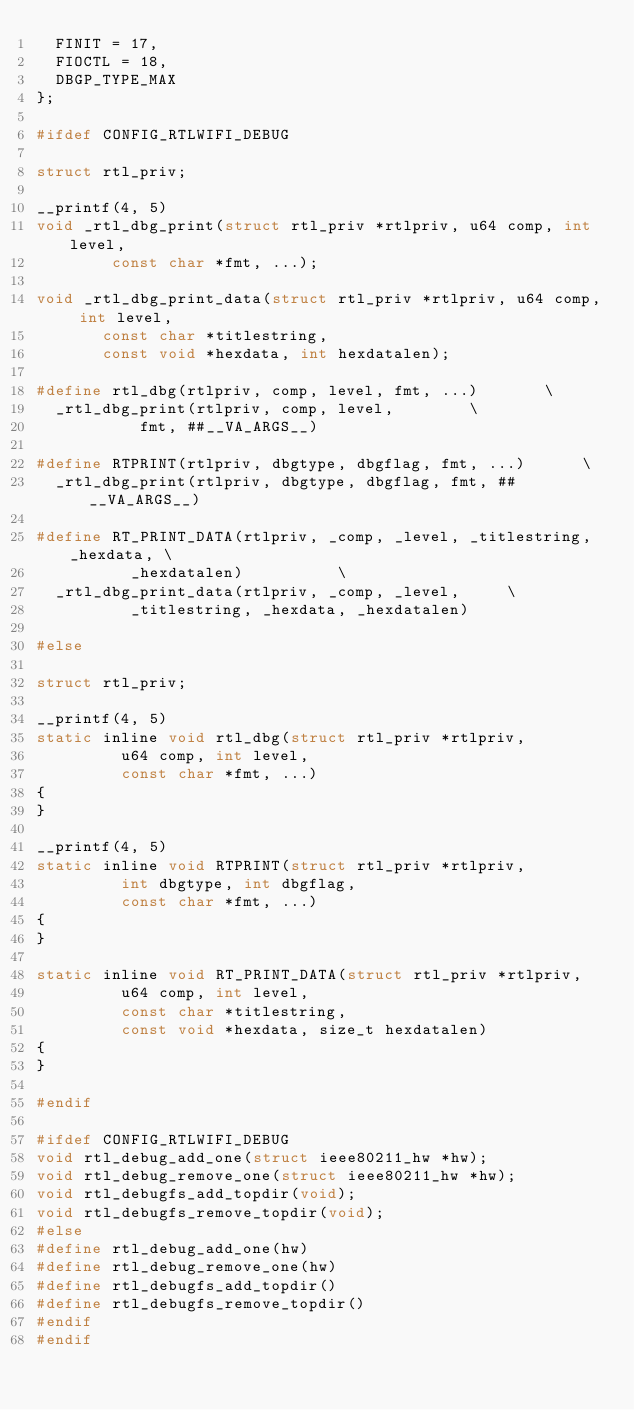<code> <loc_0><loc_0><loc_500><loc_500><_C_>	FINIT = 17,
	FIOCTL = 18,
	DBGP_TYPE_MAX
};

#ifdef CONFIG_RTLWIFI_DEBUG

struct rtl_priv;

__printf(4, 5)
void _rtl_dbg_print(struct rtl_priv *rtlpriv, u64 comp, int level,
		    const char *fmt, ...);

void _rtl_dbg_print_data(struct rtl_priv *rtlpriv, u64 comp, int level,
			 const char *titlestring,
			 const void *hexdata, int hexdatalen);

#define rtl_dbg(rtlpriv, comp, level, fmt, ...)				\
	_rtl_dbg_print(rtlpriv, comp, level,				\
		       fmt, ##__VA_ARGS__)

#define RTPRINT(rtlpriv, dbgtype, dbgflag, fmt, ...)			\
	_rtl_dbg_print(rtlpriv, dbgtype, dbgflag, fmt, ##__VA_ARGS__)

#define RT_PRINT_DATA(rtlpriv, _comp, _level, _titlestring, _hexdata,	\
		      _hexdatalen)					\
	_rtl_dbg_print_data(rtlpriv, _comp, _level,			\
			    _titlestring, _hexdata, _hexdatalen)

#else

struct rtl_priv;

__printf(4, 5)
static inline void rtl_dbg(struct rtl_priv *rtlpriv,
			   u64 comp, int level,
			   const char *fmt, ...)
{
}

__printf(4, 5)
static inline void RTPRINT(struct rtl_priv *rtlpriv,
			   int dbgtype, int dbgflag,
			   const char *fmt, ...)
{
}

static inline void RT_PRINT_DATA(struct rtl_priv *rtlpriv,
				 u64 comp, int level,
				 const char *titlestring,
				 const void *hexdata, size_t hexdatalen)
{
}

#endif

#ifdef CONFIG_RTLWIFI_DEBUG
void rtl_debug_add_one(struct ieee80211_hw *hw);
void rtl_debug_remove_one(struct ieee80211_hw *hw);
void rtl_debugfs_add_topdir(void);
void rtl_debugfs_remove_topdir(void);
#else
#define rtl_debug_add_one(hw)
#define rtl_debug_remove_one(hw)
#define rtl_debugfs_add_topdir()
#define rtl_debugfs_remove_topdir()
#endif
#endif
</code> 